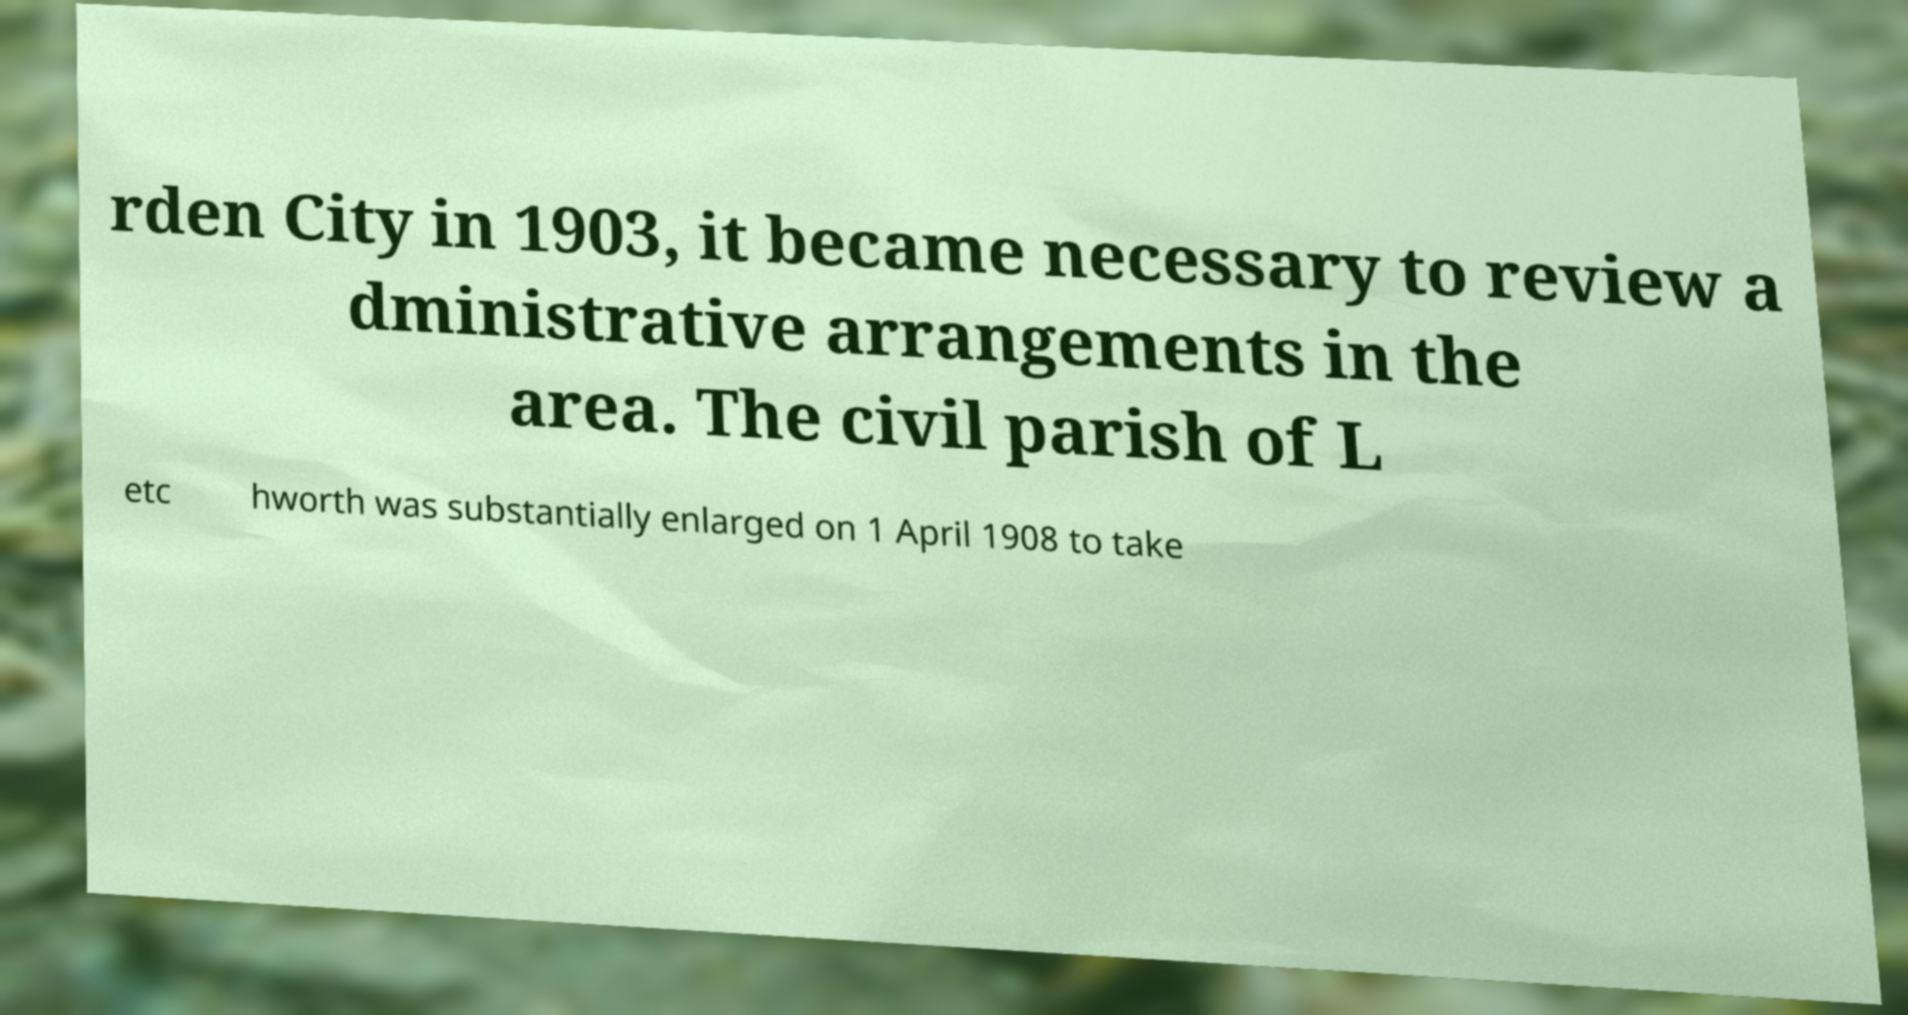Please identify and transcribe the text found in this image. rden City in 1903, it became necessary to review a dministrative arrangements in the area. The civil parish of L etc hworth was substantially enlarged on 1 April 1908 to take 